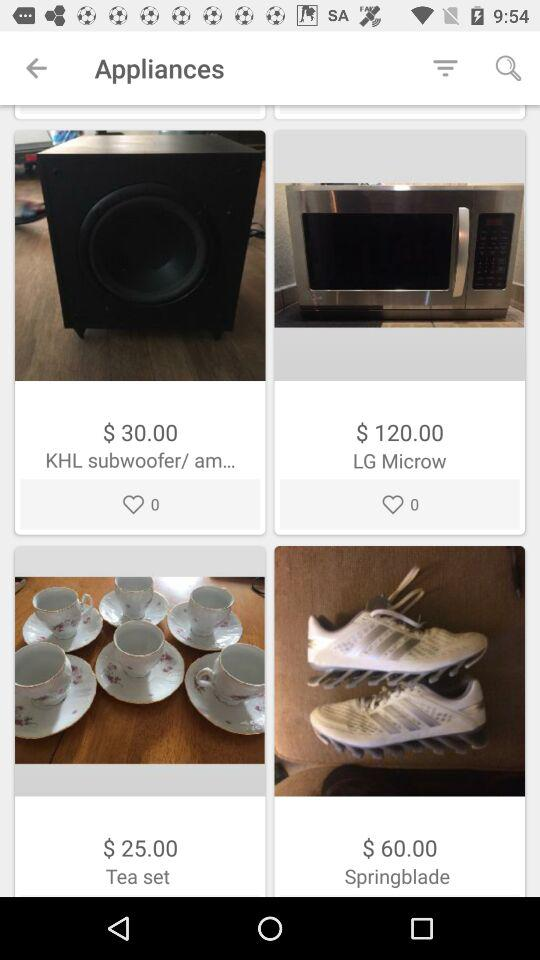What is the cost of the tea set? The cost is $25.00. 